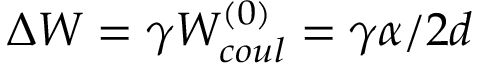Convert formula to latex. <formula><loc_0><loc_0><loc_500><loc_500>\Delta W = \gamma W _ { c o u l } ^ { ( 0 ) } = \gamma \alpha / 2 d</formula> 